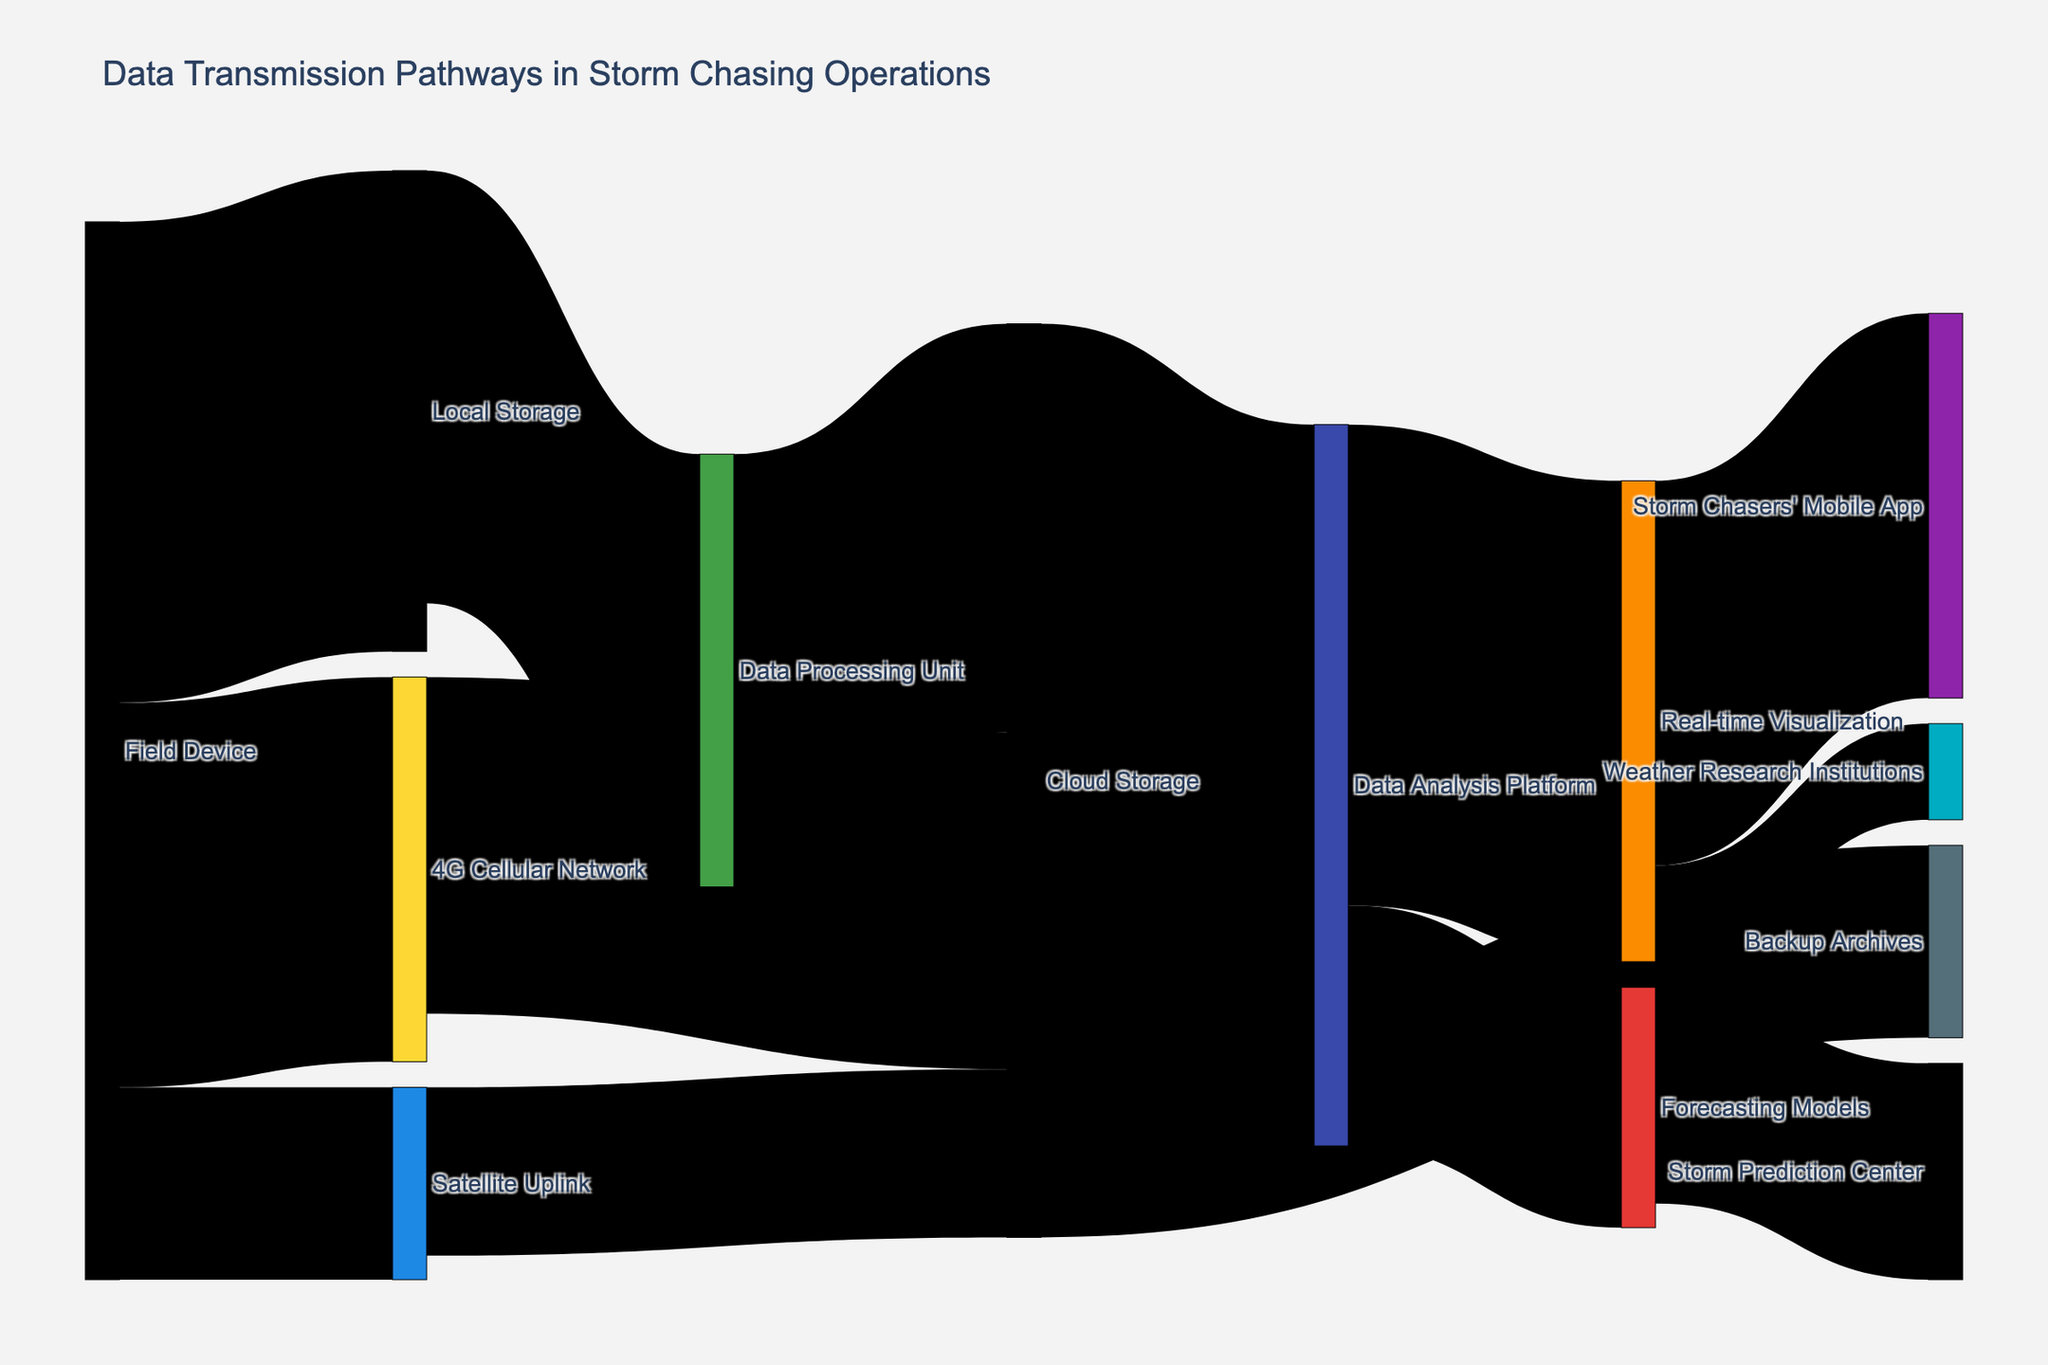What's the title of the figure? The title of the figure is displayed at the top, often in larger font size, summarizing the main purpose of the visual.
Answer: Data Transmission Pathways in Storm Chasing Operations How many pathways lead from 'Field Device'? Count all the streams that originate from 'Field Device' to other nodes. There are streams leading to 'Local Storage', '4G Cellular Network', and 'Satellite Uplink'.
Answer: Three Where does the largest data transfer occur? Look for the stream with the highest value. This stream has wider bands compared to others and is labeled with the numerical values.
Answer: From 'Field Device' to 'Local Storage' with a value of 100 What is the total amount of data flowing into 'Cloud Storage'? Sum the values of all the pathways leading to 'Cloud Storage'. Add up the flows from '4G Cellular Network', 'Satellite Uplink', and 'Data Processing Unit': 70 + 35 + 85.
Answer: 190 What percentage of data from 'Field Device' is transmitted via the '4G Cellular Network'? Calculate the value of the pathway from 'Field Device' to '4G Cellular Network' and divide it by the total data from 'Field Device', then multiply by 100%. (80/220) * 100 = 36.36%.
Answer: 36.36% Which pathway has the smallest value and what is that value? Identify the thinnest stream in the diagram which indicates the smallest value and check the labels for its specific amount.
Answer: From 'Forecasting Models' to 'Storm Prediction Center' with a value of 45 Compare the data flow from 'Local Storage' to 'Data Processing Unit' and 'Field Device' to 'Satellite Uplink'. Which is higher and by how much? Compare the values of these two pathways: 'Local Storage' to 'Data Processing Unit' is 90, and 'Field Device' to 'Satellite Uplink' is 40. Subtract the smaller value from the larger. (90 - 40).
Answer: 50 units higher from 'Local Storage' to 'Data Processing Unit' How many different devices and systems are involved in data transmission? Count the unique labels (nodes) in the whole diagram to determine the number of distinct devices and systems.
Answer: Eleven From which nodes does 'Real-time Visualization' receive data, and what's the combined value of these pathways? Identify the nodes that flow into 'Real-time Visualization' and sum their values: 'Data Analysis Platform' provides 100.
Answer: 100 What proportion of the data in 'Data Analysis Platform' goes to 'Storm Chasers' Mobile App'? Find the value of data flow from 'Data Analysis Platform' to 'Storm Chasers' Mobile App' and divide it by the total data in 'Data Analysis Platform', then multiply by 100%. (80/150) * 100%.
Answer: 53.33% 